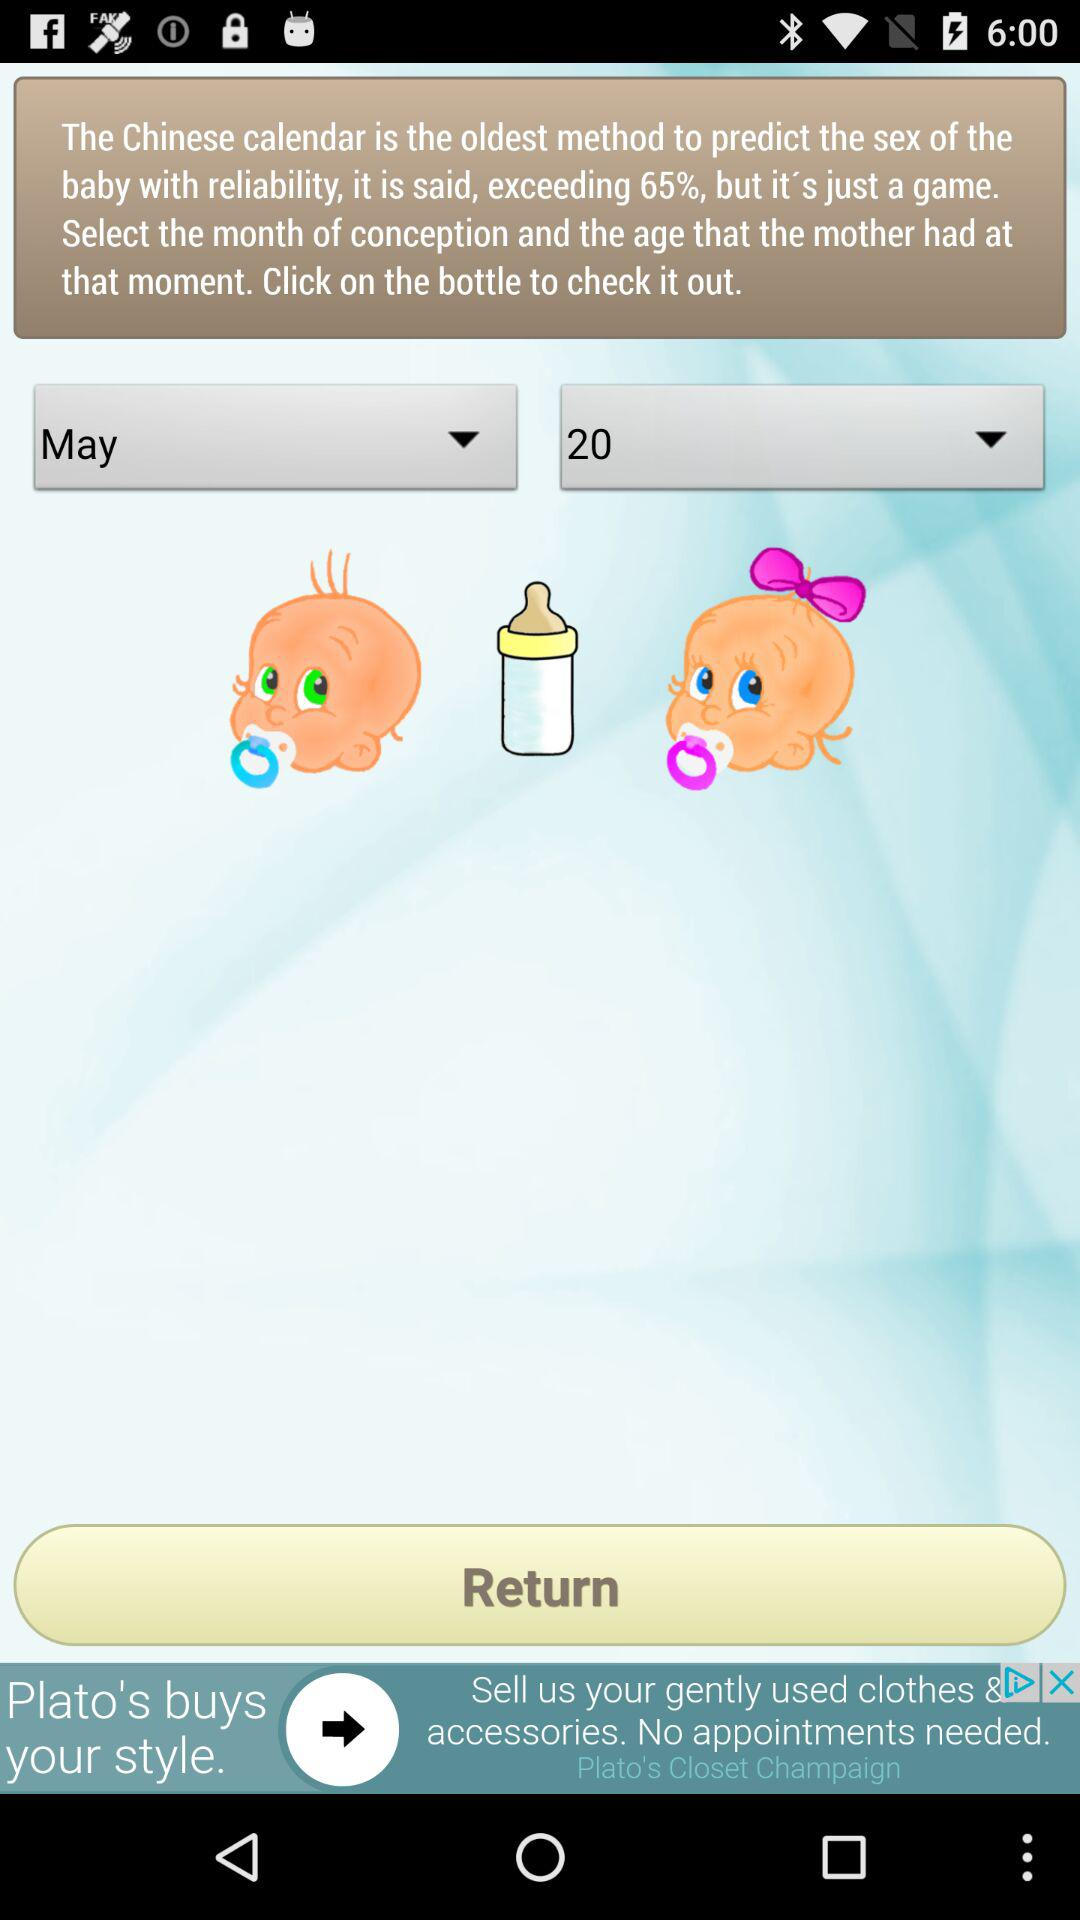What is the age of the mother? The age of the mother is 20. 